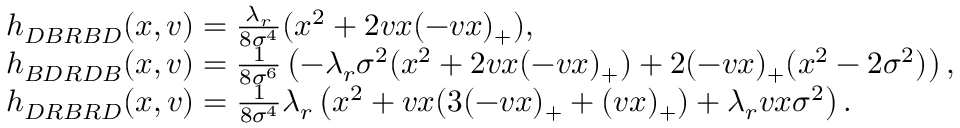Convert formula to latex. <formula><loc_0><loc_0><loc_500><loc_500>\begin{array} { r l } & { h _ { D B R B D } ( x , v ) = \frac { \lambda _ { r } } { 8 \sigma ^ { 4 } } ( x ^ { 2 } + 2 v x ( - v x ) _ { + } ) , } \\ & { h _ { B D R D B } ( x , v ) = \frac { 1 } { 8 \sigma ^ { 6 } } \left ( - \lambda _ { r } \sigma ^ { 2 } ( x ^ { 2 } + 2 v x ( - v x ) _ { + } ) + 2 ( - v x ) _ { + } ( x ^ { 2 } - 2 \sigma ^ { 2 } ) \right ) , } \\ & { h _ { D R B R D } ( x , v ) = \frac { 1 } { 8 \sigma ^ { 4 } } \lambda _ { r } \left ( x ^ { 2 } + v x ( 3 ( - v x ) _ { + } + ( v x ) _ { + } ) + \lambda _ { r } v x \sigma ^ { 2 } \right ) . } \end{array}</formula> 